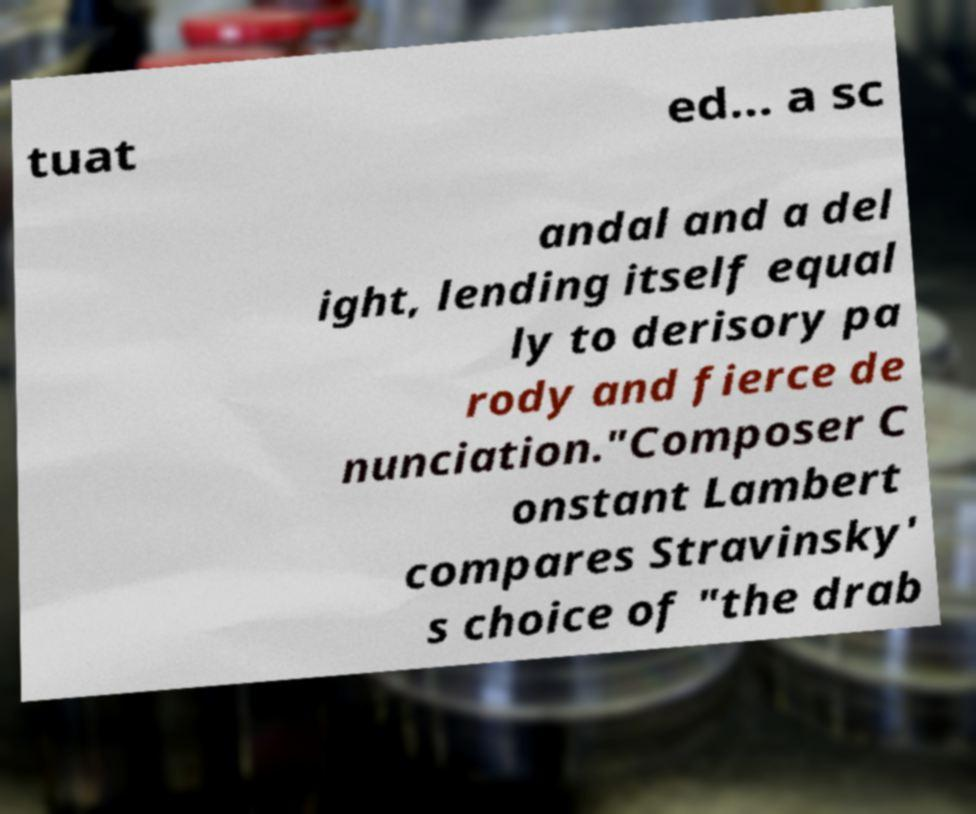Could you assist in decoding the text presented in this image and type it out clearly? tuat ed... a sc andal and a del ight, lending itself equal ly to derisory pa rody and fierce de nunciation."Composer C onstant Lambert compares Stravinsky' s choice of "the drab 